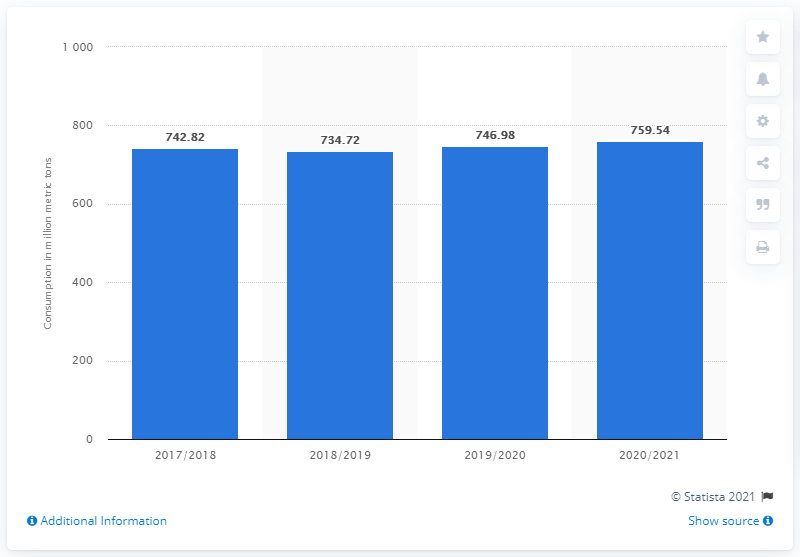Identify some key points in this picture. During the 2020/2021 marketing year, a total of 759.54 metric tons of wheat were consumed. In the 2019/2020 agricultural season, the total amount of wheat consumed worldwide was 746.98 million metric tons. 